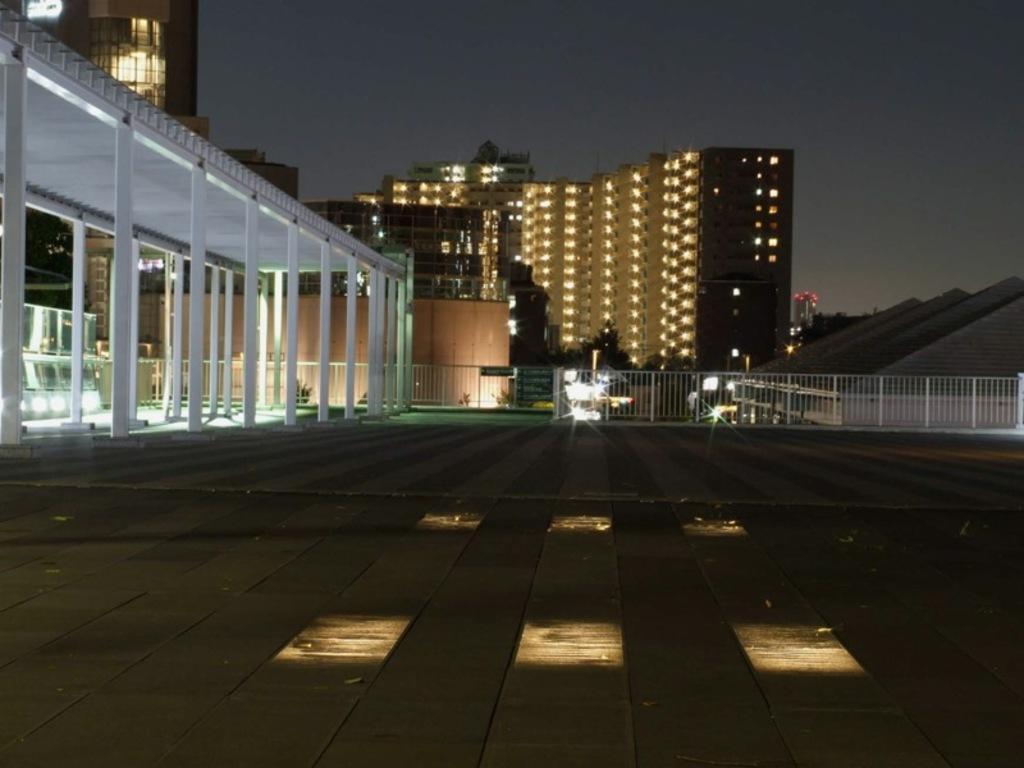In one or two sentences, can you explain what this image depicts? In this picture I can see some buildings, lights, we can see some pillars with roof and also fencing. 